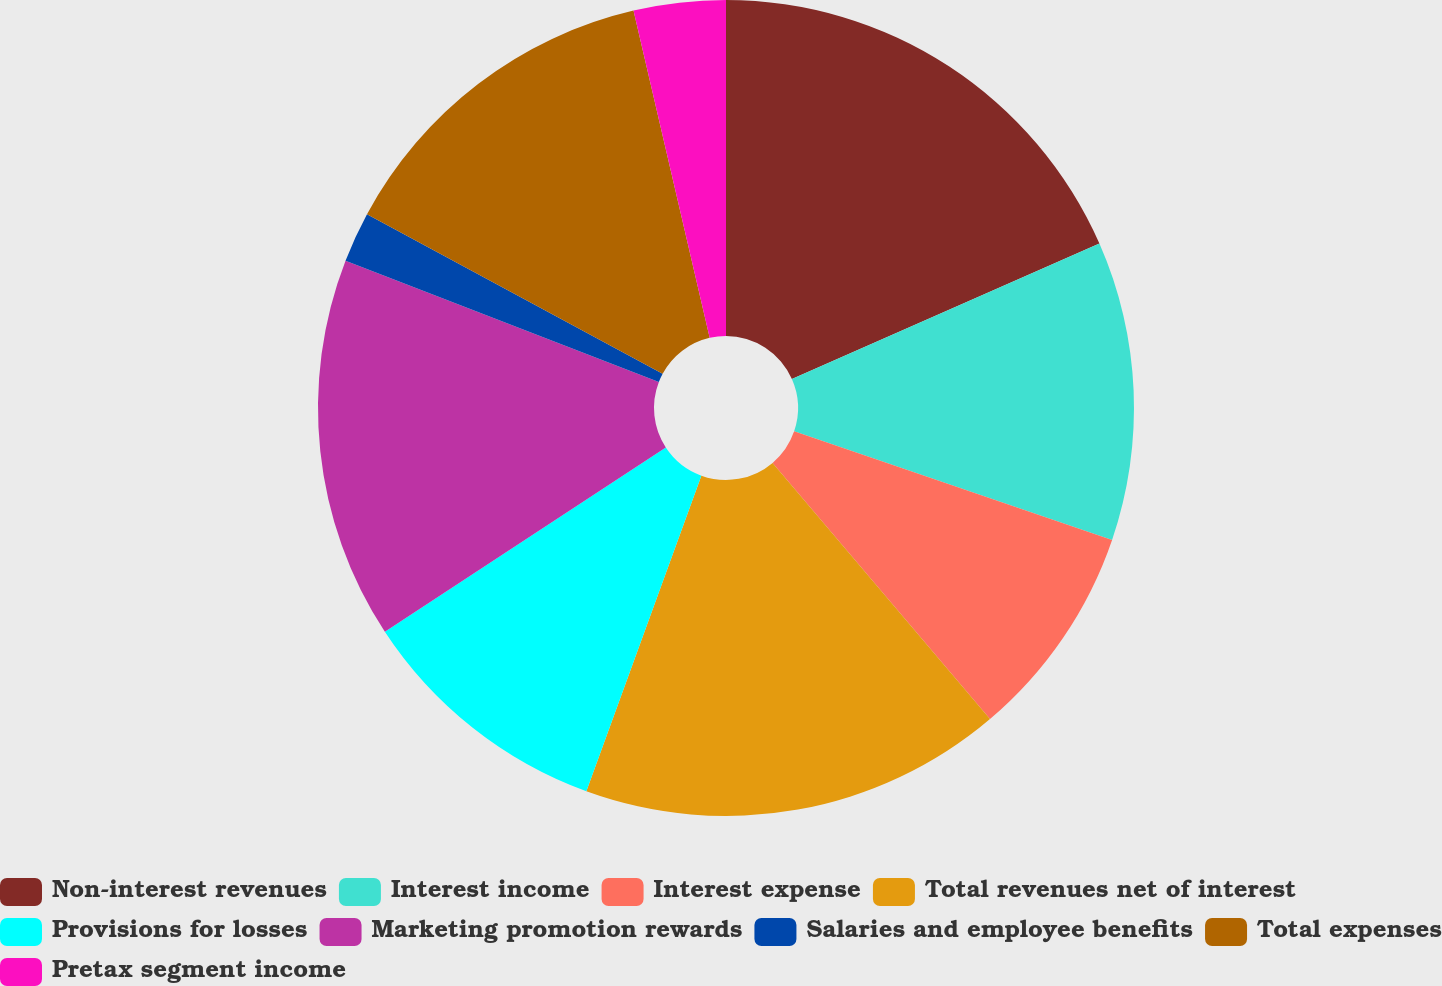Convert chart to OTSL. <chart><loc_0><loc_0><loc_500><loc_500><pie_chart><fcel>Non-interest revenues<fcel>Interest income<fcel>Interest expense<fcel>Total revenues net of interest<fcel>Provisions for losses<fcel>Marketing promotion rewards<fcel>Salaries and employee benefits<fcel>Total expenses<fcel>Pretax segment income<nl><fcel>18.4%<fcel>11.84%<fcel>8.56%<fcel>16.76%<fcel>10.2%<fcel>15.12%<fcel>2.0%<fcel>13.48%<fcel>3.64%<nl></chart> 